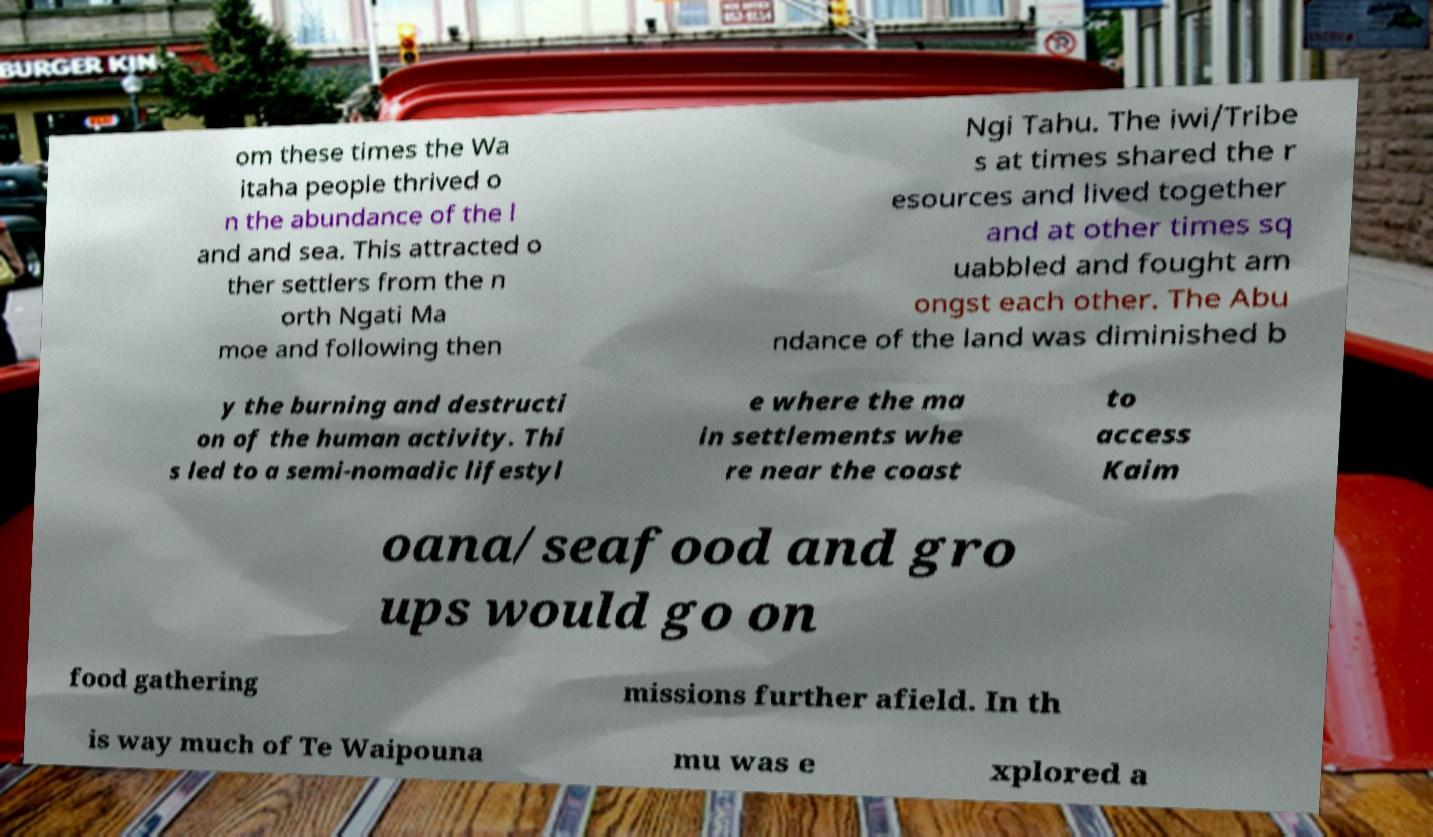What messages or text are displayed in this image? I need them in a readable, typed format. om these times the Wa itaha people thrived o n the abundance of the l and and sea. This attracted o ther settlers from the n orth Ngati Ma moe and following then Ngi Tahu. The iwi/Tribe s at times shared the r esources and lived together and at other times sq uabbled and fought am ongst each other. The Abu ndance of the land was diminished b y the burning and destructi on of the human activity. Thi s led to a semi-nomadic lifestyl e where the ma in settlements whe re near the coast to access Kaim oana/seafood and gro ups would go on food gathering missions further afield. In th is way much of Te Waipouna mu was e xplored a 